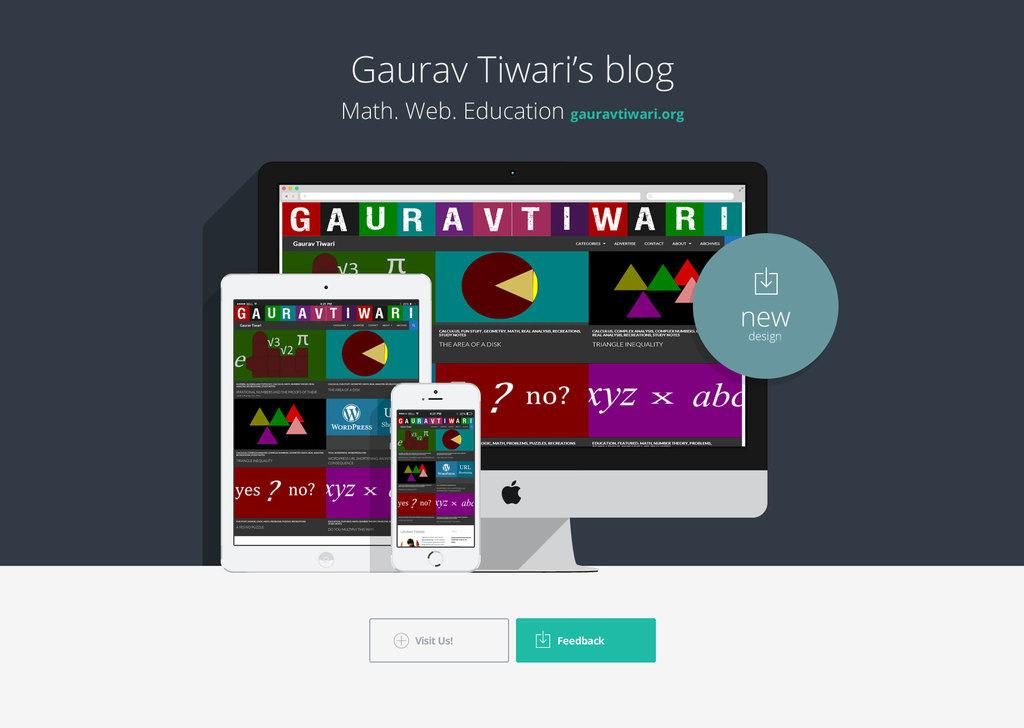<image>
Summarize the visual content of the image. The website Gauravtiwari is on a cell phone, tablet and computer monitor with a visit us and feedback buttons at the bottom. 